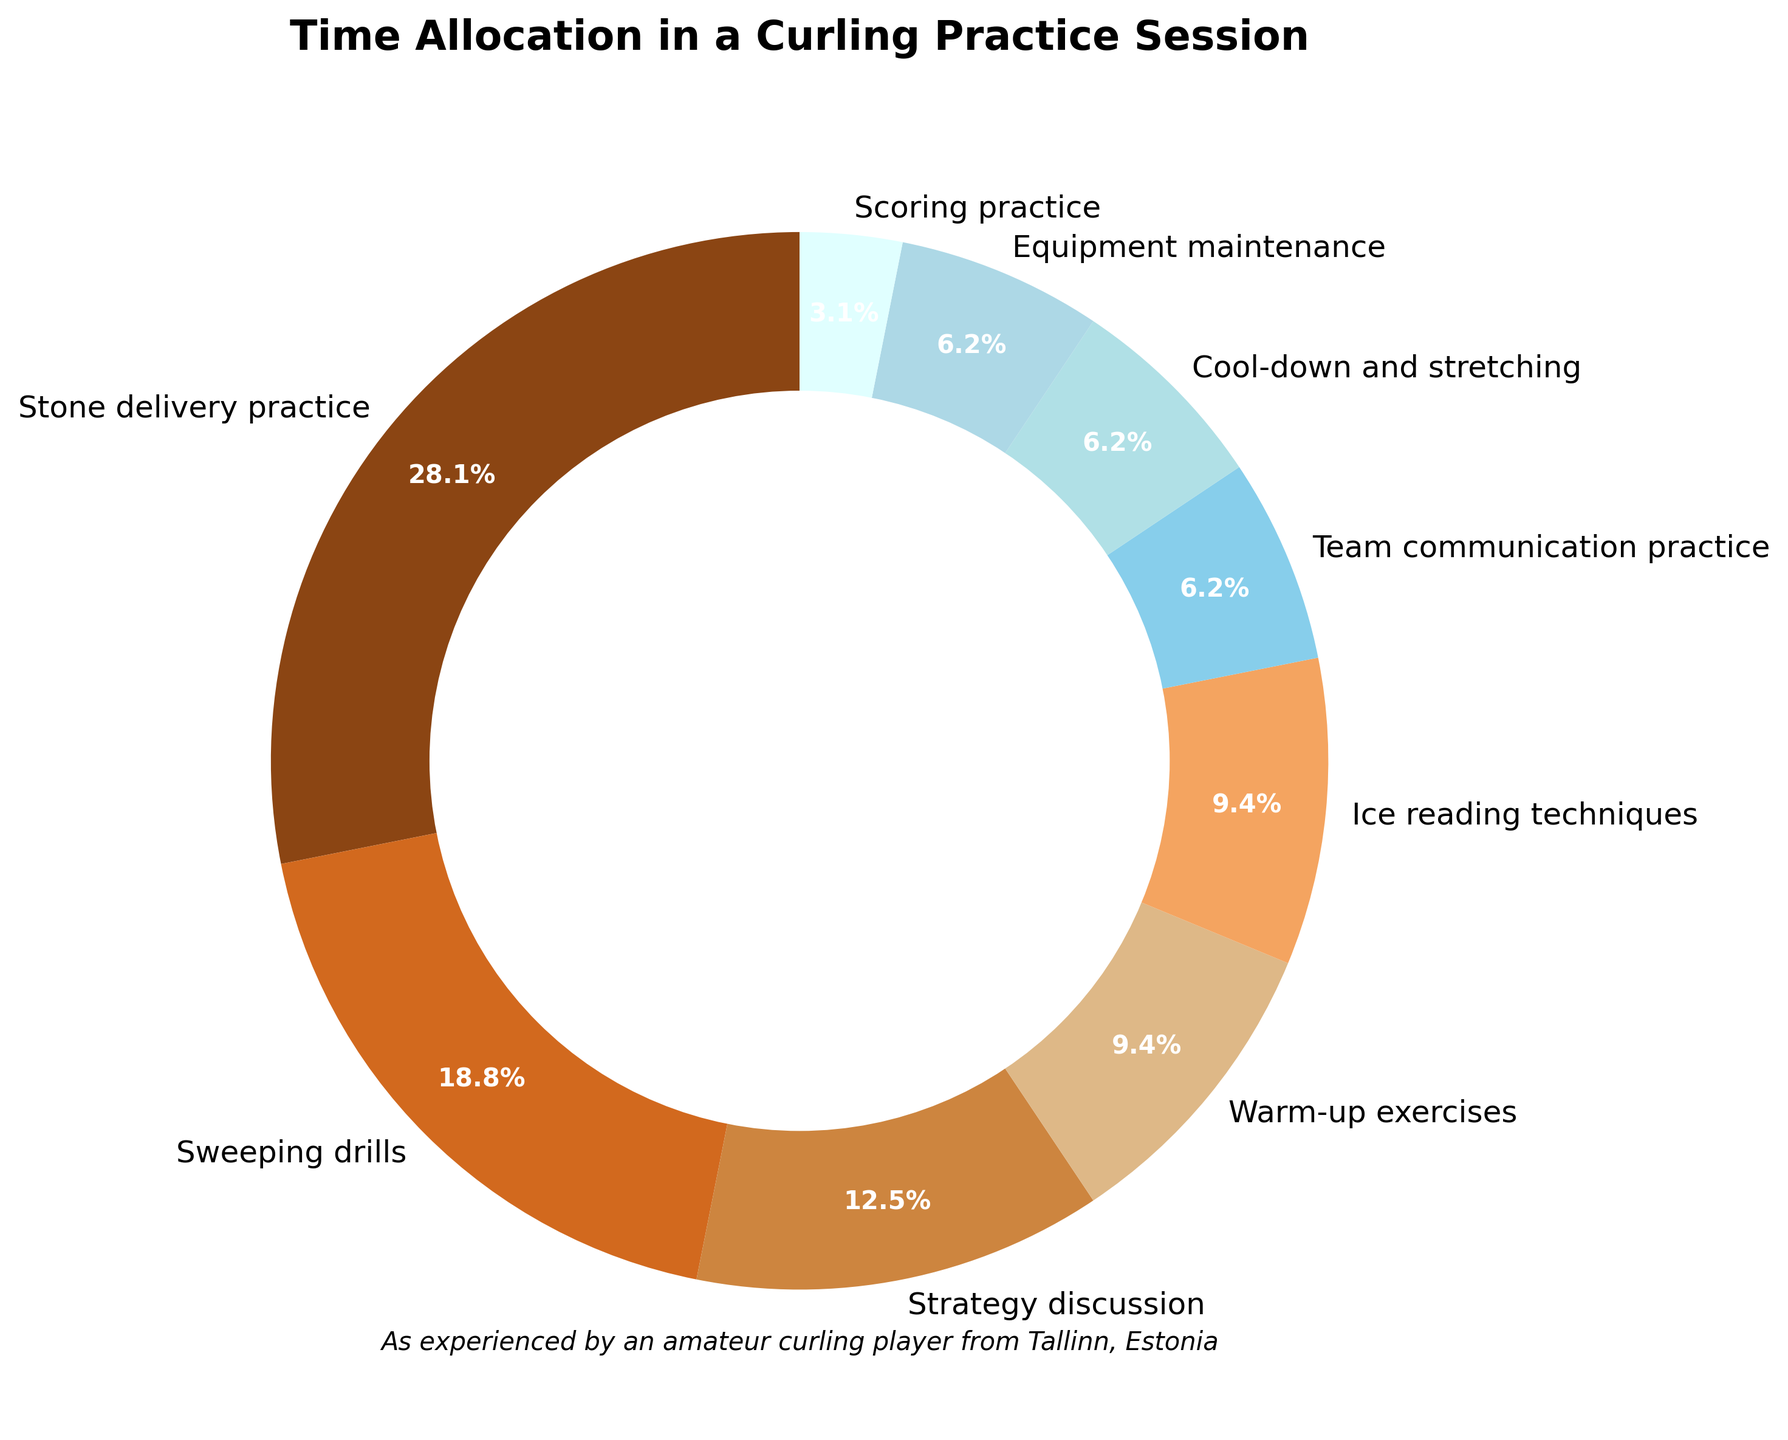Which activity takes the most time during the practice session? By looking at the pie chart, we can identify the activity segment that occupies the largest portion of the chart.
Answer: Stone delivery practice Which two activities together occupy the same amount of time as sweeping drills? Warm-up exercises and Ice reading techniques both take 15 minutes each, which sums up to 30 minutes. This matches the time allocated for sweeping drills.
Answer: Warm-up exercises and Ice reading techniques How much more time is spent on stone delivery practice compared to scoring practice? Stone delivery practice takes 45 minutes, and scoring practice takes 5 minutes. The difference is 45 - 5 = 40 minutes.
Answer: 40 minutes What percentage of the practice session is spent on warm-up exercises and cool-down and stretching combined? Warm-up exercises take 15 minutes, and cool-down and stretching take 10 minutes. The total time is 15 + 10 = 25 minutes. The practice session totals 160 minutes. The percentage is (25/160) * 100 ≈ 15.6%.
Answer: 15.6% Compare the time allocated to strategy discussion with team communication practice. Which one takes more time and by how much? Strategy discussion takes 20 minutes, and team communication practice takes 10 minutes. Hence, strategy discussion takes 20 - 10 = 10 minutes more.
Answer: Strategy discussion, 10 minutes more Which color represents the warm-up exercises in the pie chart? By visually identifying the segment labeled "Warm-up exercises" in the pie chart and its corresponding color, we see that it is represented by a dark brown color.
Answer: Dark brown How much time is spent on non-skill-specific activities (warm-up exercises, cool-down and stretching, equipment maintenance)? Adding up the times: Warm-up exercises (15 min), cool-down and stretching (10 min), equipment maintenance (10 min). The total is 15 + 10 + 10 = 35 minutes.
Answer: 35 minutes What is the smallest segment in the pie chart and what activity does it represent? The smallest segment in the pie chart corresponds to the activity that occupies the smallest amount of time. From the data, this is the scoring practice segment, which takes 5 minutes.
Answer: Scoring practice Looking at the visual distribution, which two activities combined cover the same time as the team communication practice? Cool-down and stretching takes 10 minutes, and equipment maintenance also takes 10 minutes. Separately, they each match the time for the team communication practice.
Answer: Cool-down and stretching, equipment maintenance What fraction of the practice session is spent on sweeping drills? Sweeping drills take 30 minutes out of a total of 160 minutes. The fraction is 30/160, which simplifies to 3/16.
Answer: 3/16 